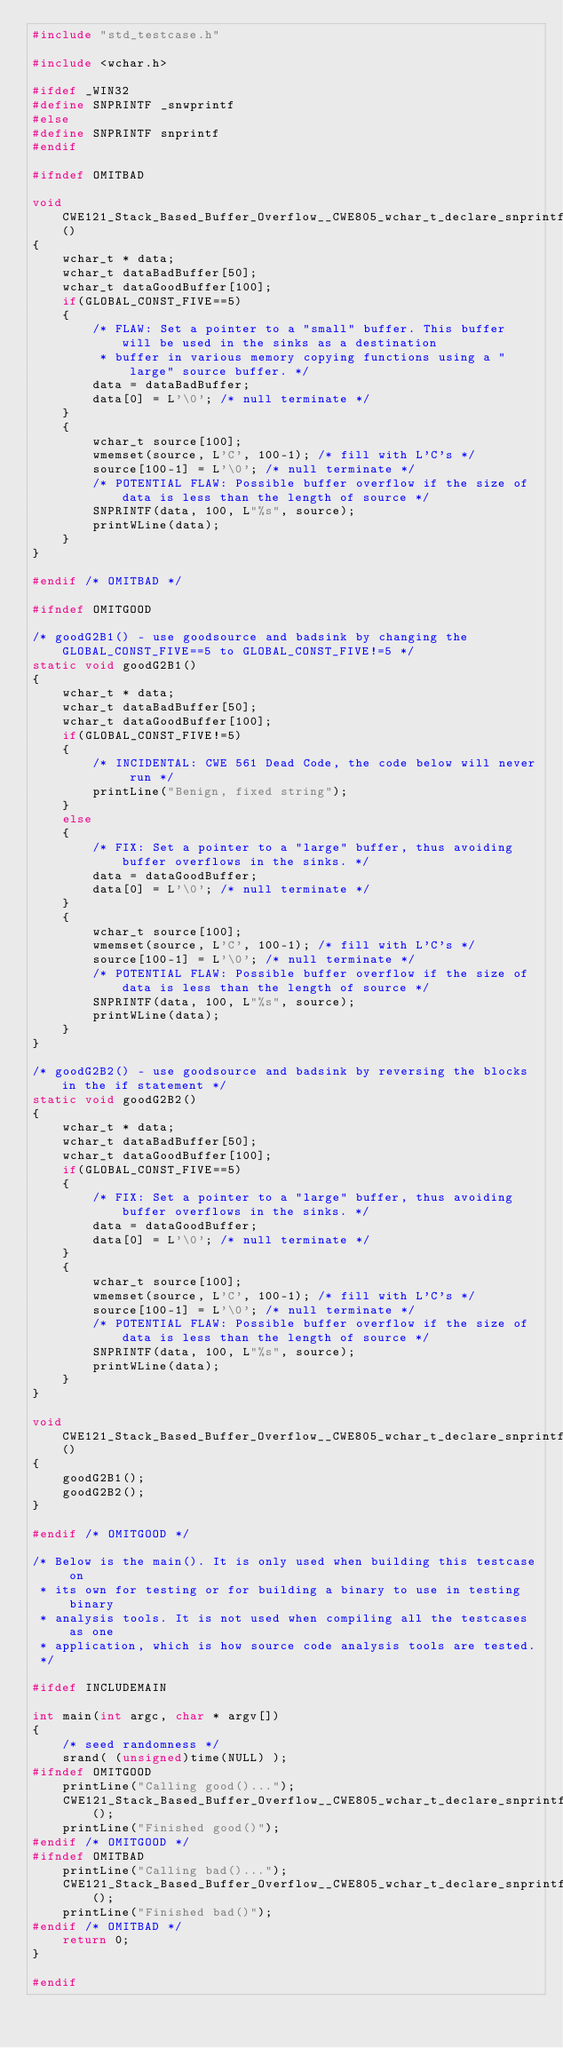Convert code to text. <code><loc_0><loc_0><loc_500><loc_500><_C_>#include "std_testcase.h"

#include <wchar.h>

#ifdef _WIN32
#define SNPRINTF _snwprintf
#else
#define SNPRINTF snprintf
#endif

#ifndef OMITBAD

void CWE121_Stack_Based_Buffer_Overflow__CWE805_wchar_t_declare_snprintf_13_bad()
{
    wchar_t * data;
    wchar_t dataBadBuffer[50];
    wchar_t dataGoodBuffer[100];
    if(GLOBAL_CONST_FIVE==5)
    {
        /* FLAW: Set a pointer to a "small" buffer. This buffer will be used in the sinks as a destination
         * buffer in various memory copying functions using a "large" source buffer. */
        data = dataBadBuffer;
        data[0] = L'\0'; /* null terminate */
    }
    {
        wchar_t source[100];
        wmemset(source, L'C', 100-1); /* fill with L'C's */
        source[100-1] = L'\0'; /* null terminate */
        /* POTENTIAL FLAW: Possible buffer overflow if the size of data is less than the length of source */
        SNPRINTF(data, 100, L"%s", source);
        printWLine(data);
    }
}

#endif /* OMITBAD */

#ifndef OMITGOOD

/* goodG2B1() - use goodsource and badsink by changing the GLOBAL_CONST_FIVE==5 to GLOBAL_CONST_FIVE!=5 */
static void goodG2B1()
{
    wchar_t * data;
    wchar_t dataBadBuffer[50];
    wchar_t dataGoodBuffer[100];
    if(GLOBAL_CONST_FIVE!=5)
    {
        /* INCIDENTAL: CWE 561 Dead Code, the code below will never run */
        printLine("Benign, fixed string");
    }
    else
    {
        /* FIX: Set a pointer to a "large" buffer, thus avoiding buffer overflows in the sinks. */
        data = dataGoodBuffer;
        data[0] = L'\0'; /* null terminate */
    }
    {
        wchar_t source[100];
        wmemset(source, L'C', 100-1); /* fill with L'C's */
        source[100-1] = L'\0'; /* null terminate */
        /* POTENTIAL FLAW: Possible buffer overflow if the size of data is less than the length of source */
        SNPRINTF(data, 100, L"%s", source);
        printWLine(data);
    }
}

/* goodG2B2() - use goodsource and badsink by reversing the blocks in the if statement */
static void goodG2B2()
{
    wchar_t * data;
    wchar_t dataBadBuffer[50];
    wchar_t dataGoodBuffer[100];
    if(GLOBAL_CONST_FIVE==5)
    {
        /* FIX: Set a pointer to a "large" buffer, thus avoiding buffer overflows in the sinks. */
        data = dataGoodBuffer;
        data[0] = L'\0'; /* null terminate */
    }
    {
        wchar_t source[100];
        wmemset(source, L'C', 100-1); /* fill with L'C's */
        source[100-1] = L'\0'; /* null terminate */
        /* POTENTIAL FLAW: Possible buffer overflow if the size of data is less than the length of source */
        SNPRINTF(data, 100, L"%s", source);
        printWLine(data);
    }
}

void CWE121_Stack_Based_Buffer_Overflow__CWE805_wchar_t_declare_snprintf_13_good()
{
    goodG2B1();
    goodG2B2();
}

#endif /* OMITGOOD */

/* Below is the main(). It is only used when building this testcase on
 * its own for testing or for building a binary to use in testing binary
 * analysis tools. It is not used when compiling all the testcases as one
 * application, which is how source code analysis tools are tested.
 */

#ifdef INCLUDEMAIN

int main(int argc, char * argv[])
{
    /* seed randomness */
    srand( (unsigned)time(NULL) );
#ifndef OMITGOOD
    printLine("Calling good()...");
    CWE121_Stack_Based_Buffer_Overflow__CWE805_wchar_t_declare_snprintf_13_good();
    printLine("Finished good()");
#endif /* OMITGOOD */
#ifndef OMITBAD
    printLine("Calling bad()...");
    CWE121_Stack_Based_Buffer_Overflow__CWE805_wchar_t_declare_snprintf_13_bad();
    printLine("Finished bad()");
#endif /* OMITBAD */
    return 0;
}

#endif
</code> 